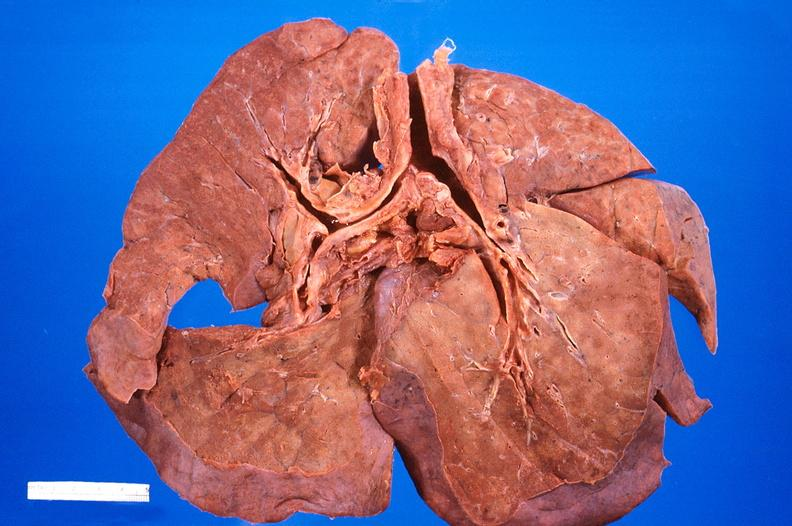what is present?
Answer the question using a single word or phrase. Respiratory 